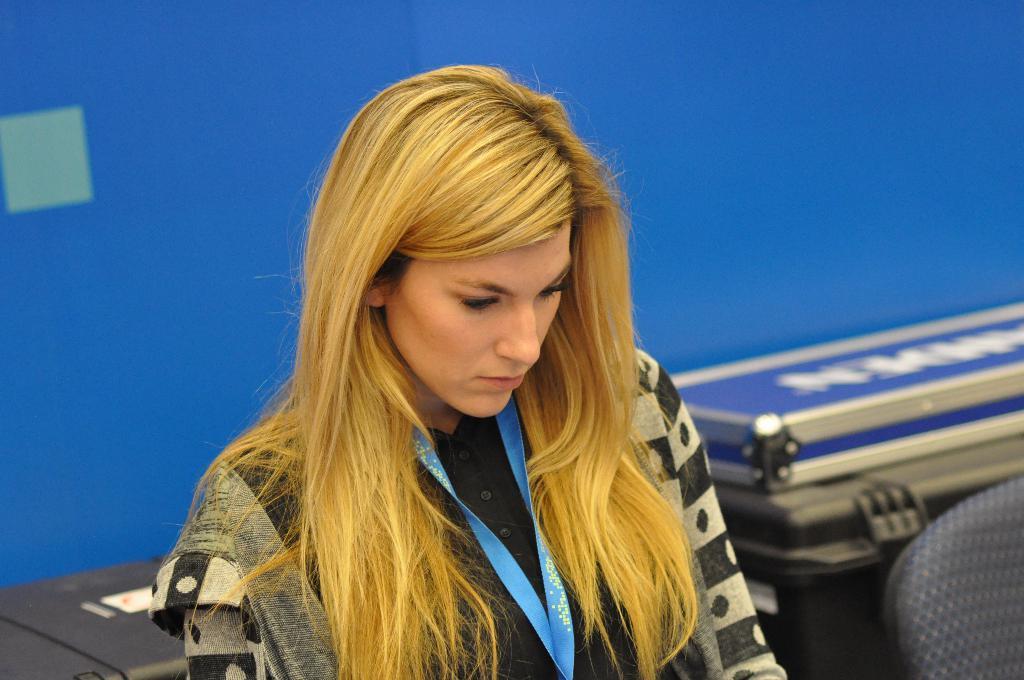Describe this image in one or two sentences. In this image we can see there is a girl sitting on the chair. In the background there is a wall. 